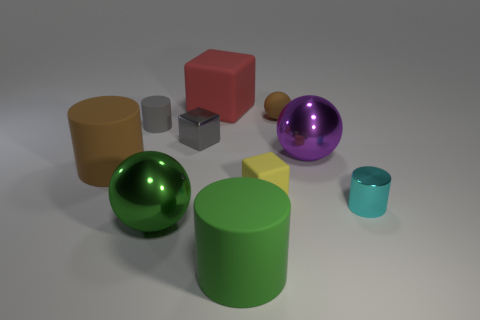Subtract all cylinders. How many objects are left? 6 Add 9 green metallic balls. How many green metallic balls are left? 10 Add 4 green shiny objects. How many green shiny objects exist? 5 Subtract 0 blue blocks. How many objects are left? 10 Subtract all large yellow shiny objects. Subtract all gray metal things. How many objects are left? 9 